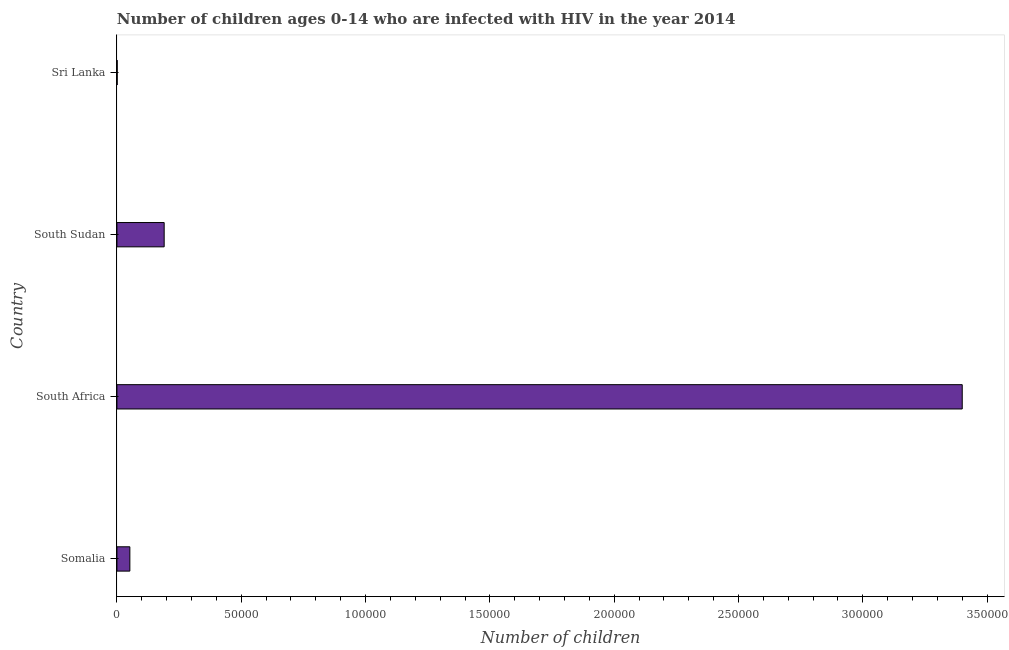Does the graph contain any zero values?
Give a very brief answer. No. What is the title of the graph?
Your answer should be very brief. Number of children ages 0-14 who are infected with HIV in the year 2014. What is the label or title of the X-axis?
Keep it short and to the point. Number of children. What is the label or title of the Y-axis?
Provide a short and direct response. Country. In which country was the number of children living with hiv maximum?
Your response must be concise. South Africa. In which country was the number of children living with hiv minimum?
Keep it short and to the point. Sri Lanka. What is the sum of the number of children living with hiv?
Offer a terse response. 3.64e+05. What is the difference between the number of children living with hiv in Somalia and South Sudan?
Provide a succinct answer. -1.38e+04. What is the average number of children living with hiv per country?
Offer a very short reply. 9.11e+04. What is the median number of children living with hiv?
Your answer should be compact. 1.21e+04. What is the ratio of the number of children living with hiv in Somalia to that in South Africa?
Your answer should be compact. 0.01. Is the number of children living with hiv in Somalia less than that in Sri Lanka?
Offer a very short reply. No. What is the difference between the highest and the second highest number of children living with hiv?
Provide a short and direct response. 3.21e+05. Is the sum of the number of children living with hiv in Somalia and South Sudan greater than the maximum number of children living with hiv across all countries?
Offer a terse response. No. What is the difference between the highest and the lowest number of children living with hiv?
Provide a short and direct response. 3.40e+05. In how many countries, is the number of children living with hiv greater than the average number of children living with hiv taken over all countries?
Your answer should be very brief. 1. Are all the bars in the graph horizontal?
Offer a very short reply. Yes. How many countries are there in the graph?
Keep it short and to the point. 4. What is the Number of children in Somalia?
Give a very brief answer. 5200. What is the Number of children in South Sudan?
Provide a short and direct response. 1.90e+04. What is the difference between the Number of children in Somalia and South Africa?
Ensure brevity in your answer.  -3.35e+05. What is the difference between the Number of children in Somalia and South Sudan?
Offer a very short reply. -1.38e+04. What is the difference between the Number of children in Somalia and Sri Lanka?
Your answer should be very brief. 5100. What is the difference between the Number of children in South Africa and South Sudan?
Offer a terse response. 3.21e+05. What is the difference between the Number of children in South Africa and Sri Lanka?
Your answer should be compact. 3.40e+05. What is the difference between the Number of children in South Sudan and Sri Lanka?
Offer a very short reply. 1.89e+04. What is the ratio of the Number of children in Somalia to that in South Africa?
Make the answer very short. 0.01. What is the ratio of the Number of children in Somalia to that in South Sudan?
Give a very brief answer. 0.27. What is the ratio of the Number of children in South Africa to that in South Sudan?
Provide a short and direct response. 17.89. What is the ratio of the Number of children in South Africa to that in Sri Lanka?
Provide a short and direct response. 3400. What is the ratio of the Number of children in South Sudan to that in Sri Lanka?
Offer a very short reply. 190. 